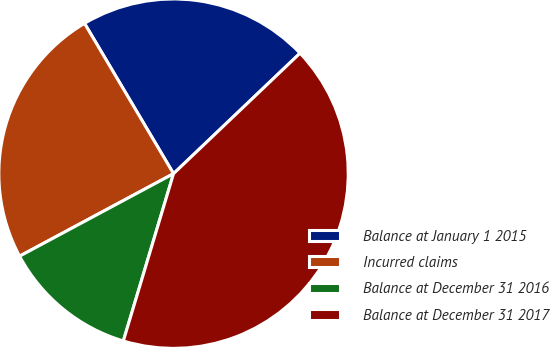Convert chart. <chart><loc_0><loc_0><loc_500><loc_500><pie_chart><fcel>Balance at January 1 2015<fcel>Incurred claims<fcel>Balance at December 31 2016<fcel>Balance at December 31 2017<nl><fcel>21.4%<fcel>24.32%<fcel>12.53%<fcel>41.75%<nl></chart> 